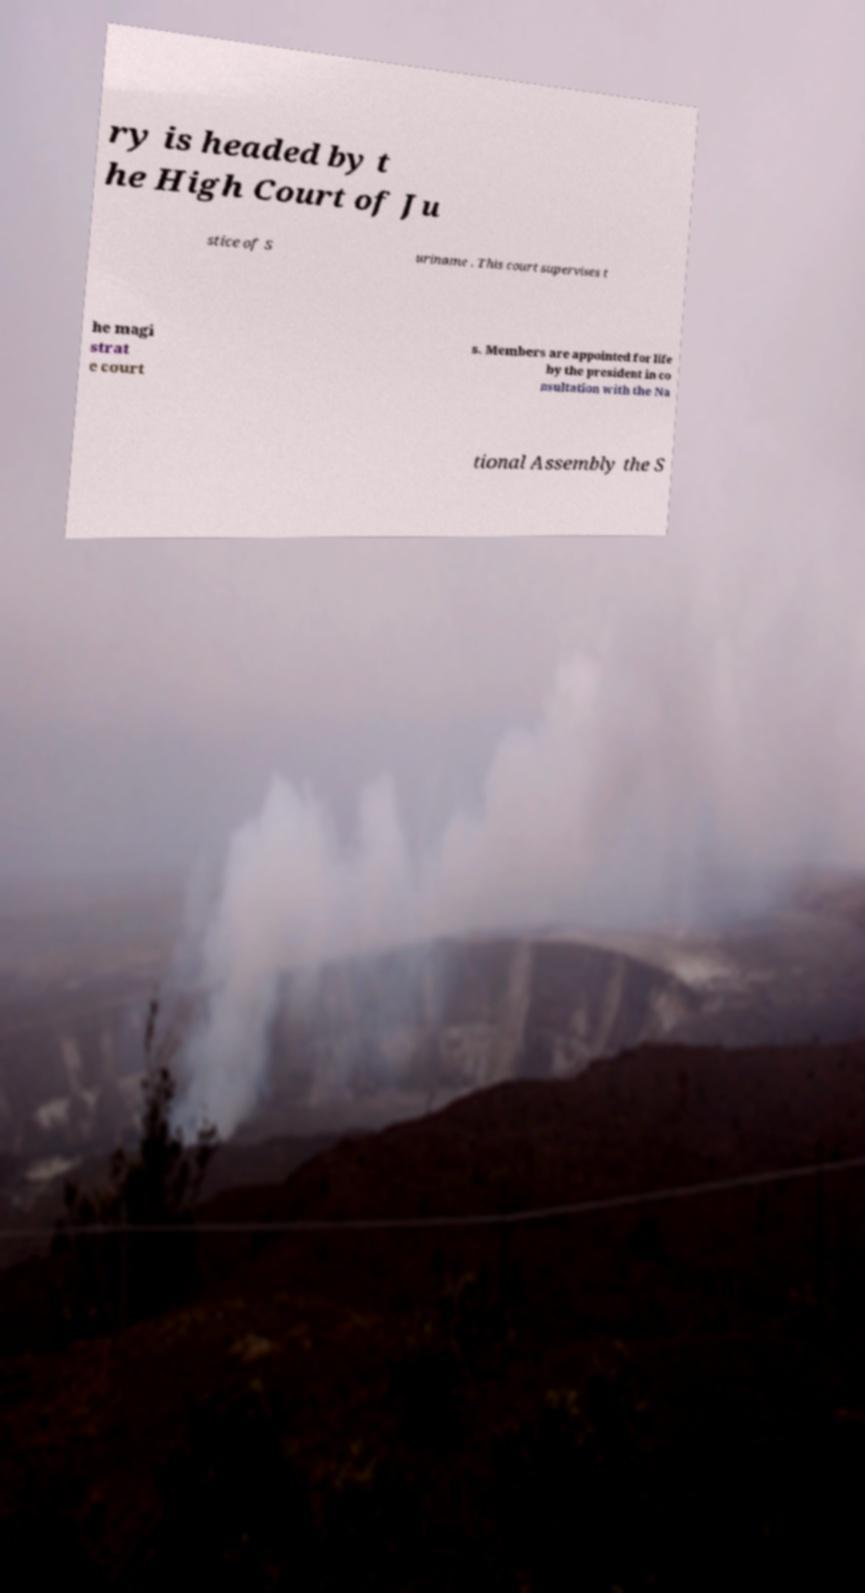Can you accurately transcribe the text from the provided image for me? ry is headed by t he High Court of Ju stice of S uriname . This court supervises t he magi strat e court s. Members are appointed for life by the president in co nsultation with the Na tional Assembly the S 